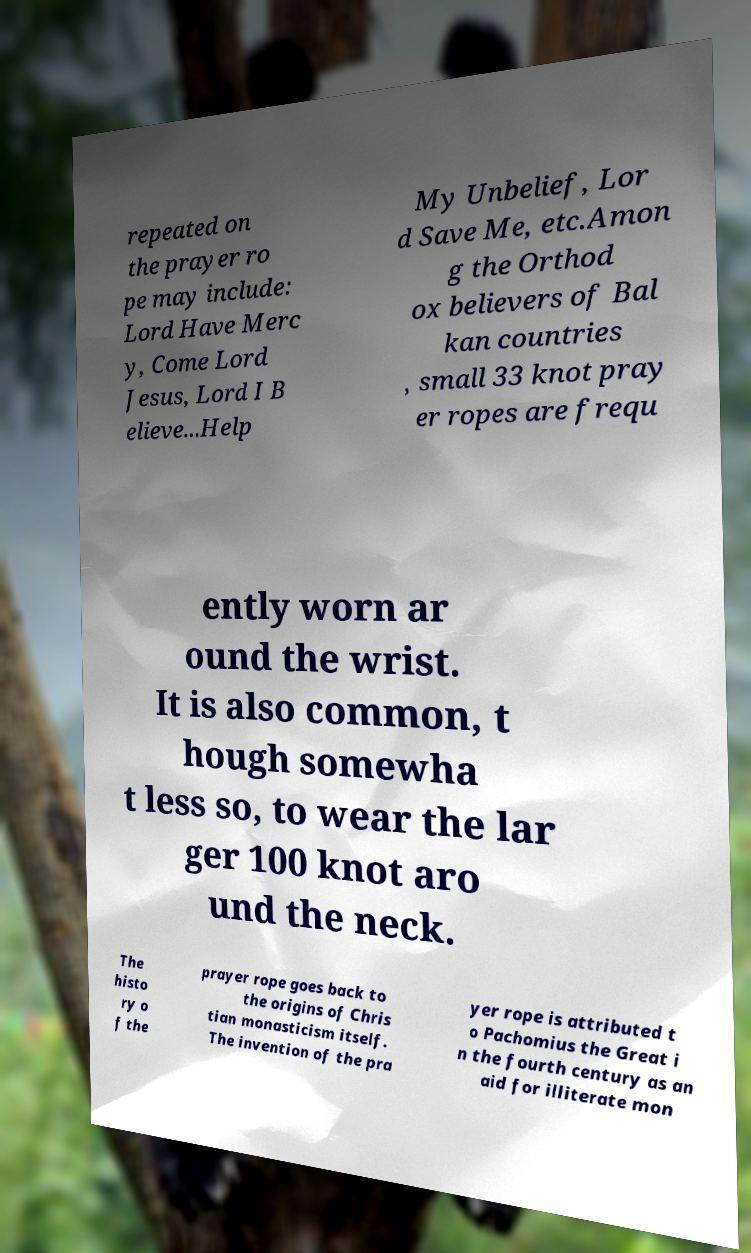There's text embedded in this image that I need extracted. Can you transcribe it verbatim? repeated on the prayer ro pe may include: Lord Have Merc y, Come Lord Jesus, Lord I B elieve...Help My Unbelief, Lor d Save Me, etc.Amon g the Orthod ox believers of Bal kan countries , small 33 knot pray er ropes are frequ ently worn ar ound the wrist. It is also common, t hough somewha t less so, to wear the lar ger 100 knot aro und the neck. The histo ry o f the prayer rope goes back to the origins of Chris tian monasticism itself. The invention of the pra yer rope is attributed t o Pachomius the Great i n the fourth century as an aid for illiterate mon 